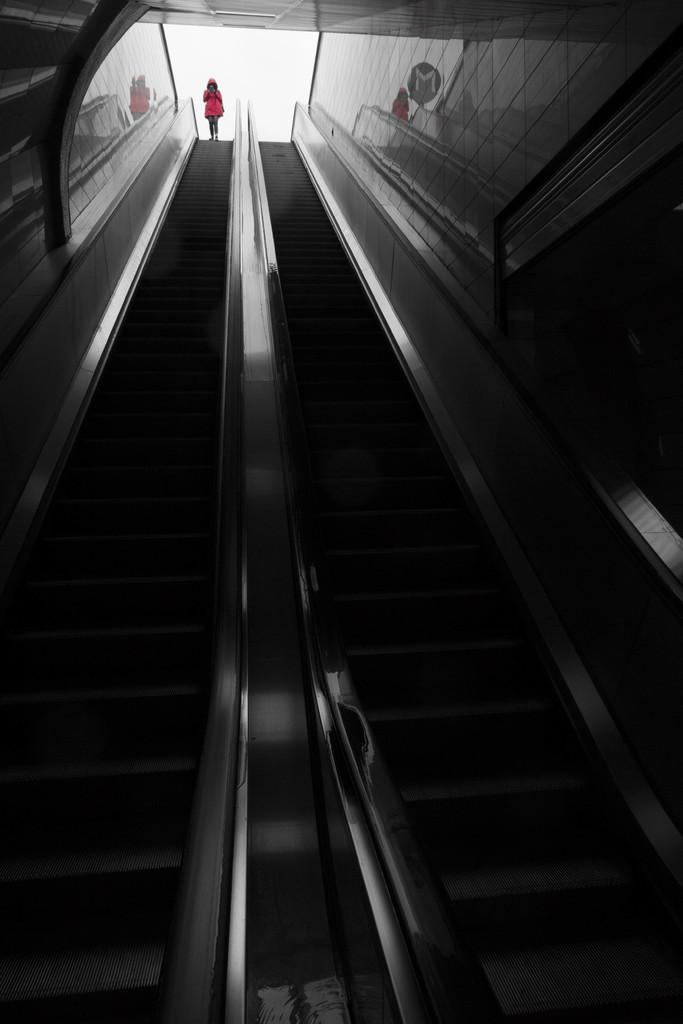What type of structure is present in the image? There are stairs in the image. Can you describe the person in the image? There is a person in the image, and they are wearing a red dress. What type of fruit is being used to write with in the image? There is no fruit present in the image, and therefore no such activity can be observed. How many legs does the person in the image have? The person in the image has two legs, as is typical for humans. 